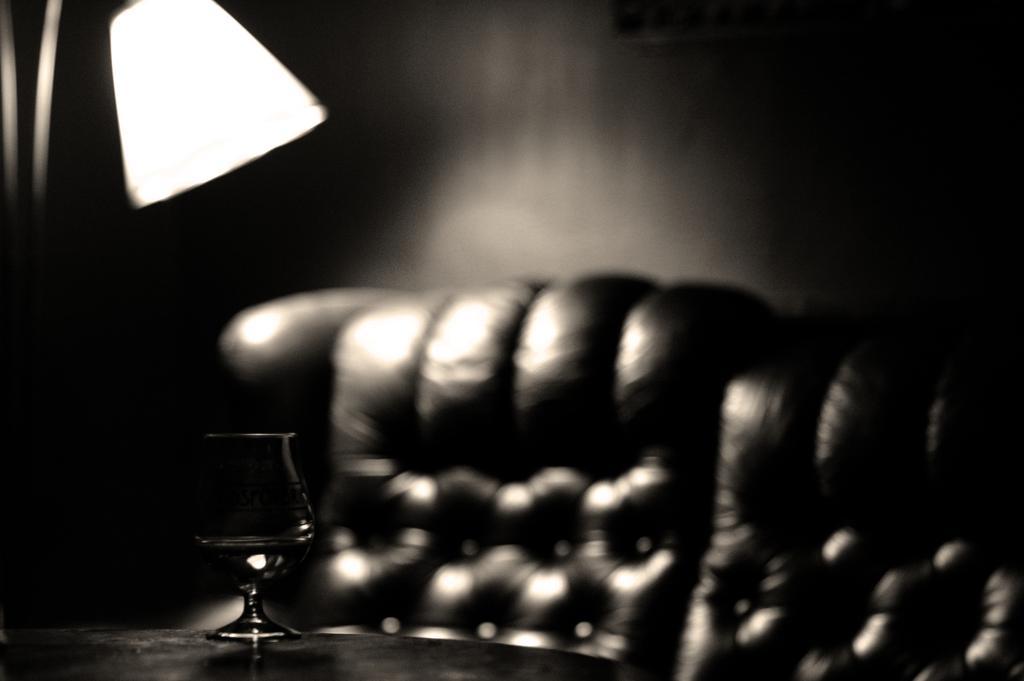Describe this image in one or two sentences. In this image I can see a lamp on the left, a glass in the front and a couch at the back. This is a black and white image. 